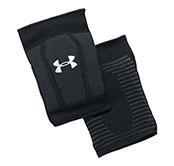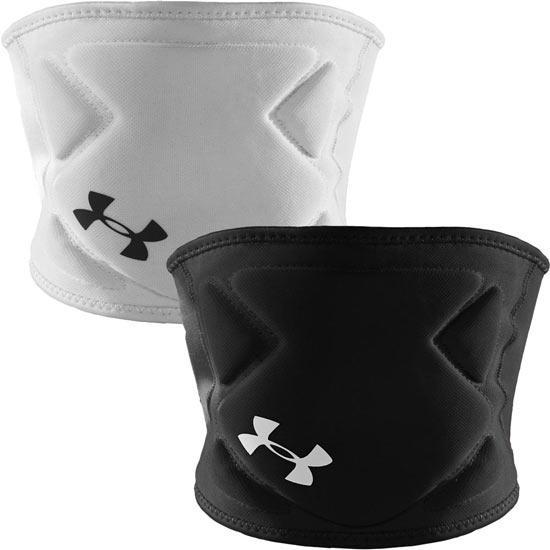The first image is the image on the left, the second image is the image on the right. Evaluate the accuracy of this statement regarding the images: "Together, the images include both white knee pads and black knee pads only.". Is it true? Answer yes or no. Yes. 